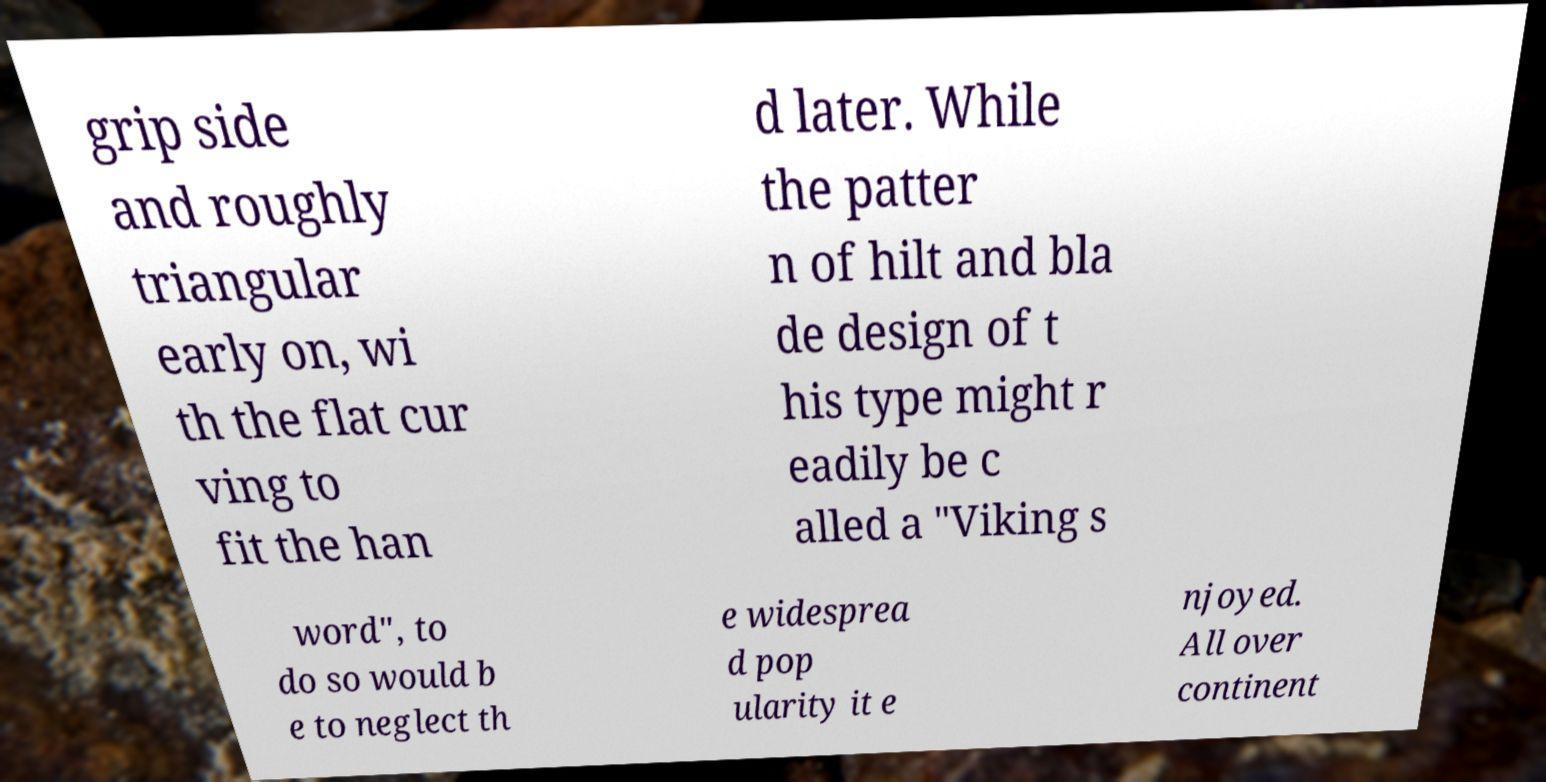What messages or text are displayed in this image? I need them in a readable, typed format. grip side and roughly triangular early on, wi th the flat cur ving to fit the han d later. While the patter n of hilt and bla de design of t his type might r eadily be c alled a "Viking s word", to do so would b e to neglect th e widesprea d pop ularity it e njoyed. All over continent 